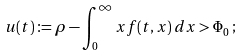<formula> <loc_0><loc_0><loc_500><loc_500>u ( t ) \coloneqq \rho - \int _ { 0 } ^ { \infty } x f ( t , x ) \, d x > \Phi _ { 0 } \, ;</formula> 